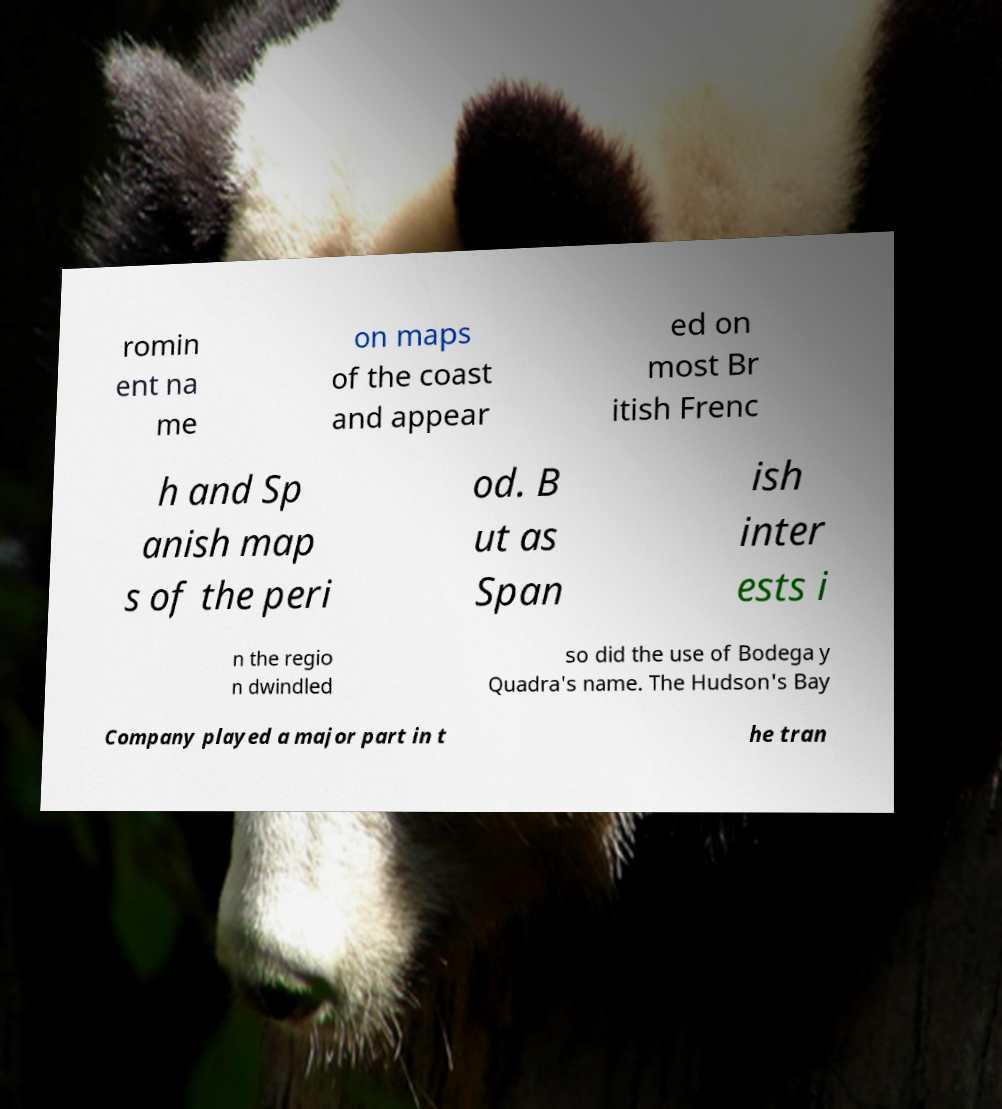For documentation purposes, I need the text within this image transcribed. Could you provide that? romin ent na me on maps of the coast and appear ed on most Br itish Frenc h and Sp anish map s of the peri od. B ut as Span ish inter ests i n the regio n dwindled so did the use of Bodega y Quadra's name. The Hudson's Bay Company played a major part in t he tran 